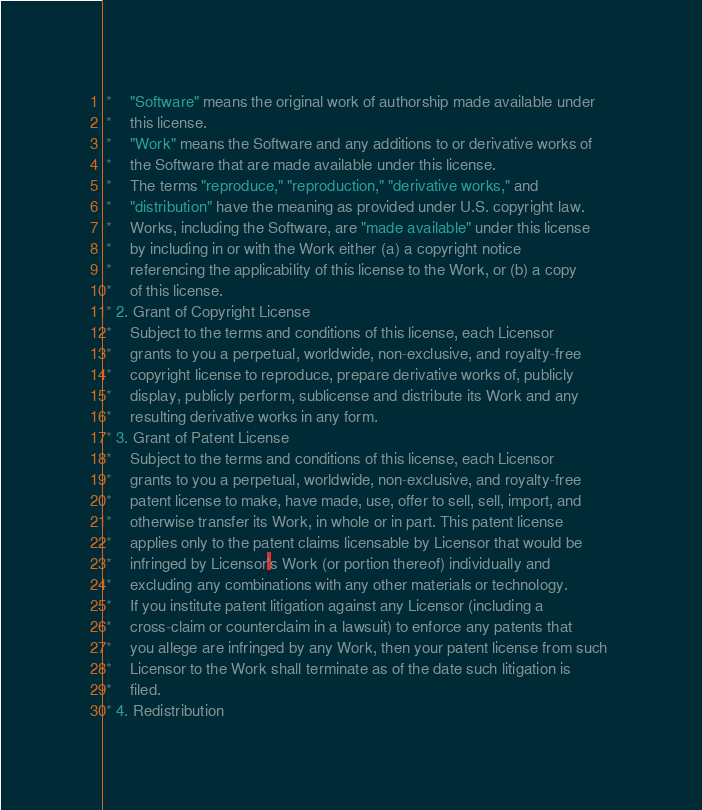<code> <loc_0><loc_0><loc_500><loc_500><_C_> *    "Software" means the original work of authorship made available under 
 *    this license.
 *    "Work" means the Software and any additions to or derivative works of 
 *    the Software that are made available under this license.
 *    The terms "reproduce," "reproduction," "derivative works," and 
 *    "distribution" have the meaning as provided under U.S. copyright law.
 *    Works, including the Software, are "made available" under this license 
 *    by including in or with the Work either (a) a copyright notice 
 *    referencing the applicability of this license to the Work, or (b) a copy 
 *    of this license.
 * 2. Grant of Copyright License
 *    Subject to the terms and conditions of this license, each Licensor 
 *    grants to you a perpetual, worldwide, non-exclusive, and royalty-free 
 *    copyright license to reproduce, prepare derivative works of, publicly 
 *    display, publicly perform, sublicense and distribute its Work and any 
 *    resulting derivative works in any form.
 * 3. Grant of Patent License
 *    Subject to the terms and conditions of this license, each Licensor 
 *    grants to you a perpetual, worldwide, non-exclusive, and royalty-free 
 *    patent license to make, have made, use, offer to sell, sell, import, and 
 *    otherwise transfer its Work, in whole or in part. This patent license 
 *    applies only to the patent claims licensable by Licensor that would be 
 *    infringed by Licensor's Work (or portion thereof) individually and 
 *    excluding any combinations with any other materials or technology.
 *    If you institute patent litigation against any Licensor (including a 
 *    cross-claim or counterclaim in a lawsuit) to enforce any patents that 
 *    you allege are infringed by any Work, then your patent license from such 
 *    Licensor to the Work shall terminate as of the date such litigation is 
 *    filed.
 * 4. Redistribution</code> 